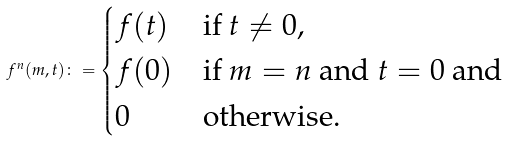Convert formula to latex. <formula><loc_0><loc_0><loc_500><loc_500>f ^ { n } ( m , t ) \colon = \begin{cases} f ( t ) & \text {if $t\not=0$,} \\ f ( 0 ) & \text {if $m=n$ and $t=0$ and} \\ 0 & \text {otherwise.} \end{cases}</formula> 